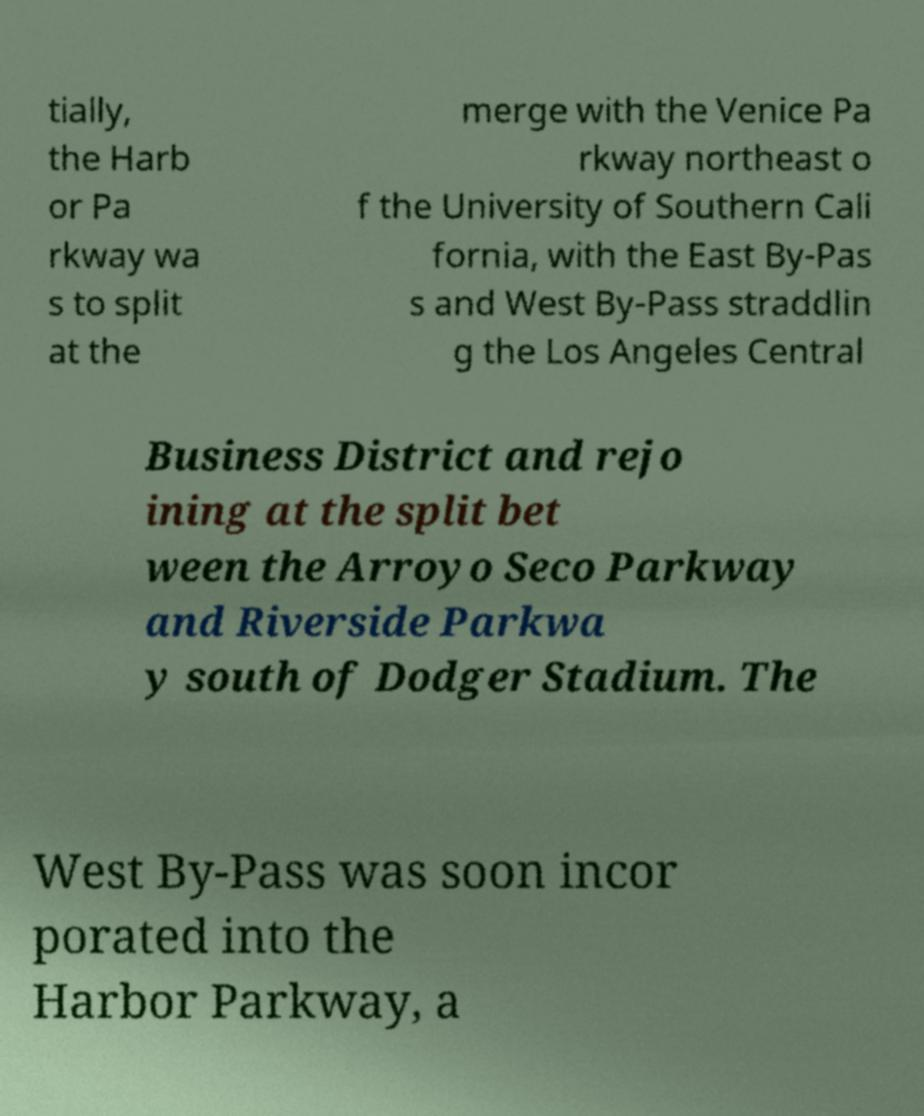What messages or text are displayed in this image? I need them in a readable, typed format. tially, the Harb or Pa rkway wa s to split at the merge with the Venice Pa rkway northeast o f the University of Southern Cali fornia, with the East By-Pas s and West By-Pass straddlin g the Los Angeles Central Business District and rejo ining at the split bet ween the Arroyo Seco Parkway and Riverside Parkwa y south of Dodger Stadium. The West By-Pass was soon incor porated into the Harbor Parkway, a 